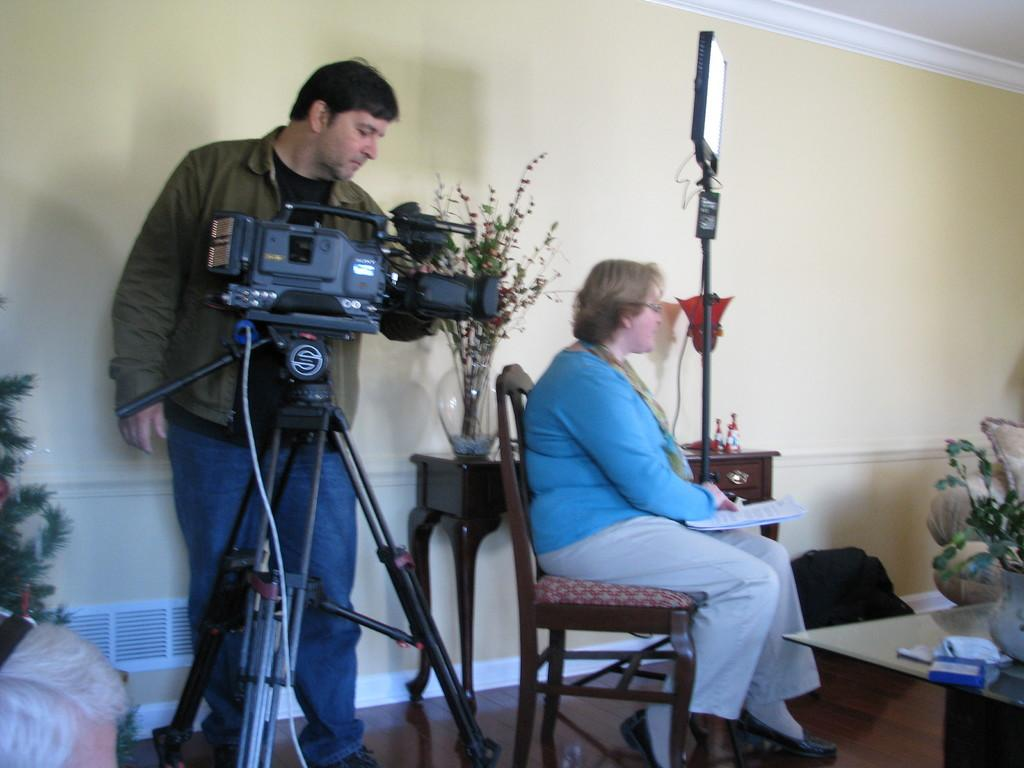What is one of the main structures in the image? There is a wall in the image. What device is visible in the image? There is a camera in the image. What are the people in the image doing? A man is standing, and a woman is sitting in the image. What is the woman sitting on? The woman is sitting on a chair. What is in front of the woman? There is a table in front of the woman. What type of sand can be seen on the floor in the image? There is no sand present on the floor in the image. What is the woman writing on the table in the image? The woman is not writing on the table in the image; she is sitting on a chair with a table in front of her. 